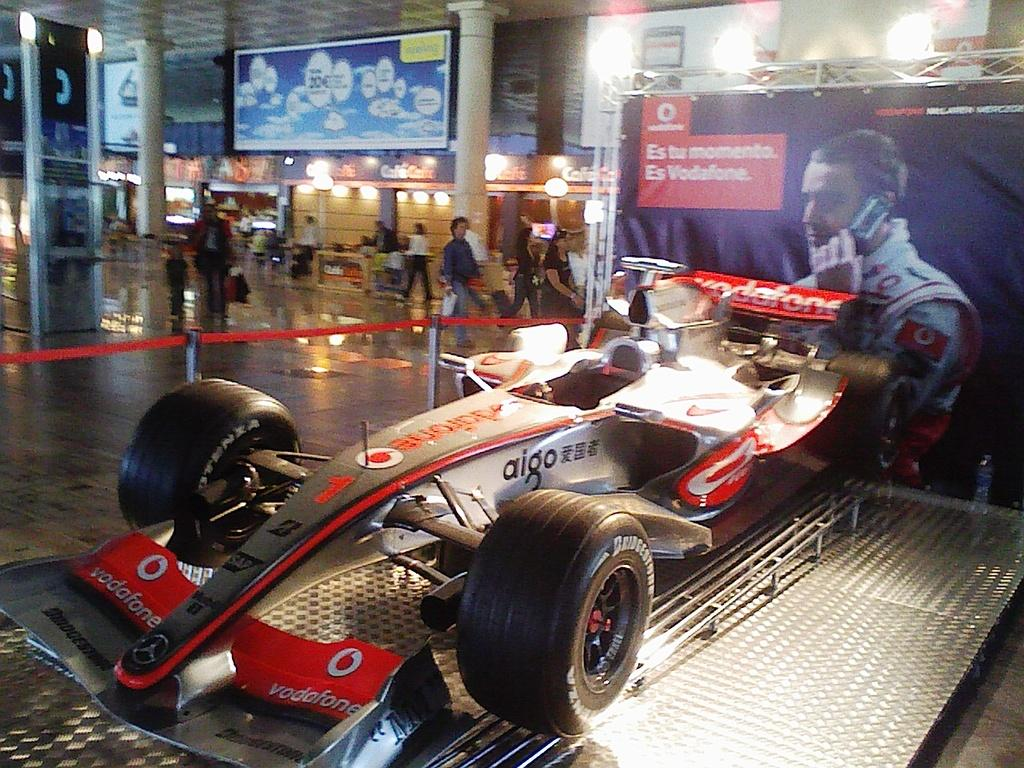What type of structure is visible in the image? There is a banner truss in the image. What other objects can be seen in the image? There are boards, lights, pillars, and barrier poles visible in the image. What is the surface that people and objects are standing on in the image? There is a floor in the image. Can you describe the people in the image? There are people present in the image. What is the vehicle on the right side of the image placed on? The vehicle is on a platform on the right side of the image. What type of wine is being served in the image? There is no wine present in the image. Are there any dolls visible in the image? There are no dolls present in the image. 